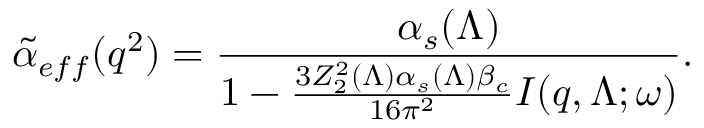<formula> <loc_0><loc_0><loc_500><loc_500>{ \tilde { \alpha } } _ { e f f } ( q ^ { 2 } ) = { \frac { \alpha _ { s } ( \Lambda ) } { 1 - { \frac { 3 Z _ { 2 } ^ { 2 } ( \Lambda ) \alpha _ { s } ( \Lambda ) \beta _ { c } } { 1 6 \pi ^ { 2 } } } I ( q , \Lambda ; \omega ) } } .</formula> 